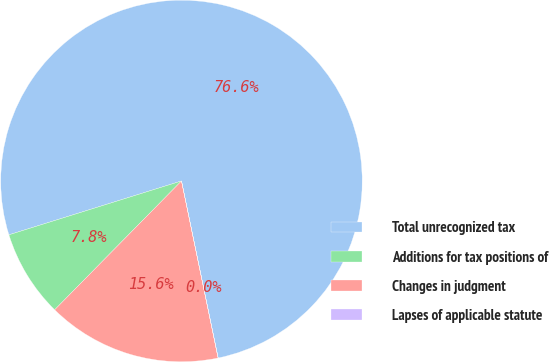Convert chart. <chart><loc_0><loc_0><loc_500><loc_500><pie_chart><fcel>Total unrecognized tax<fcel>Additions for tax positions of<fcel>Changes in judgment<fcel>Lapses of applicable statute<nl><fcel>76.56%<fcel>7.81%<fcel>15.62%<fcel>0.01%<nl></chart> 